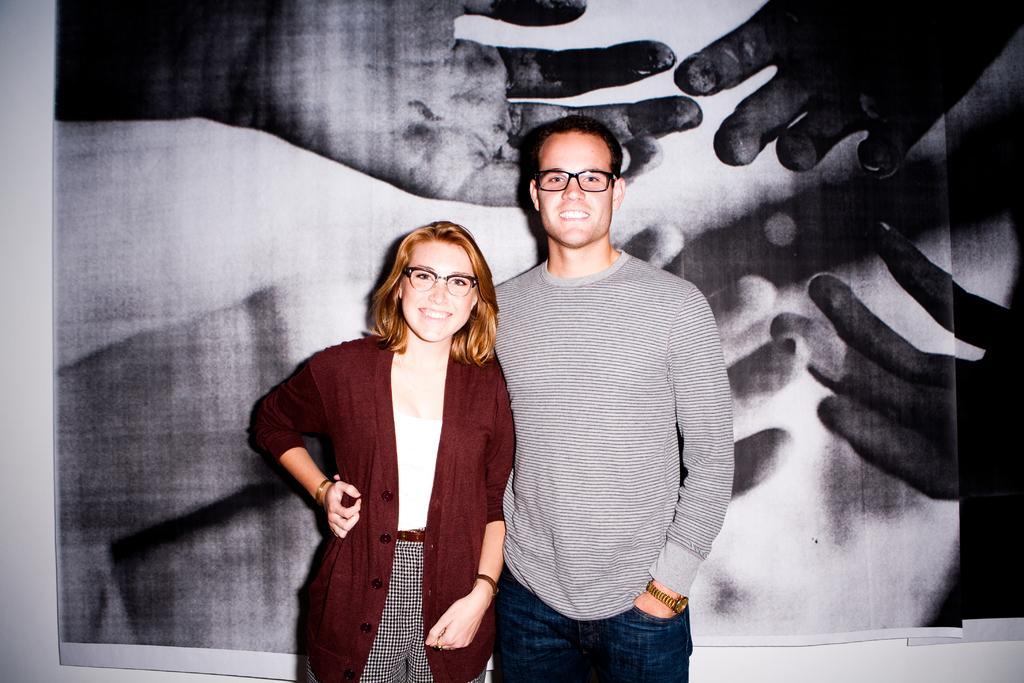Please provide a concise description of this image. In this image I can see a woman and a man are standing and smiling. In the background I can see the white colored wall and a huge photograph attached to the wall. 